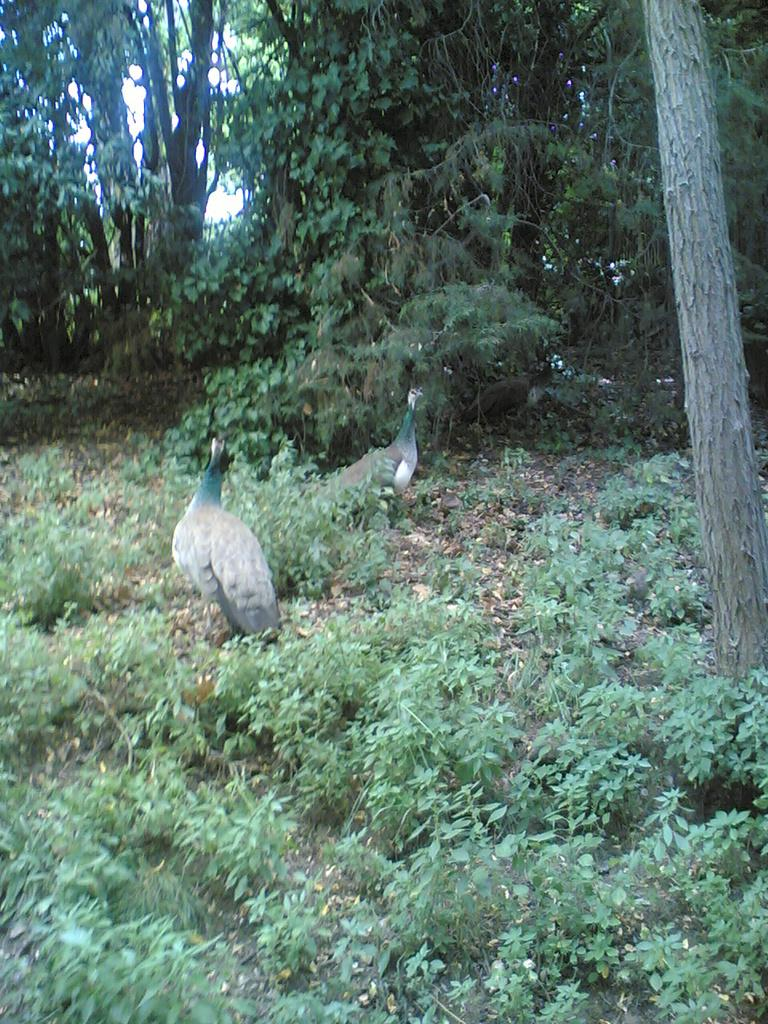What type of vegetation can be seen in the image? There are many trees and plants in the image. How many animals are present in the image? There are two animals in the image. What type of jam is being spread on the trousers in the image? There is no jam or trousers present in the image; it features trees, plants, and animals. 